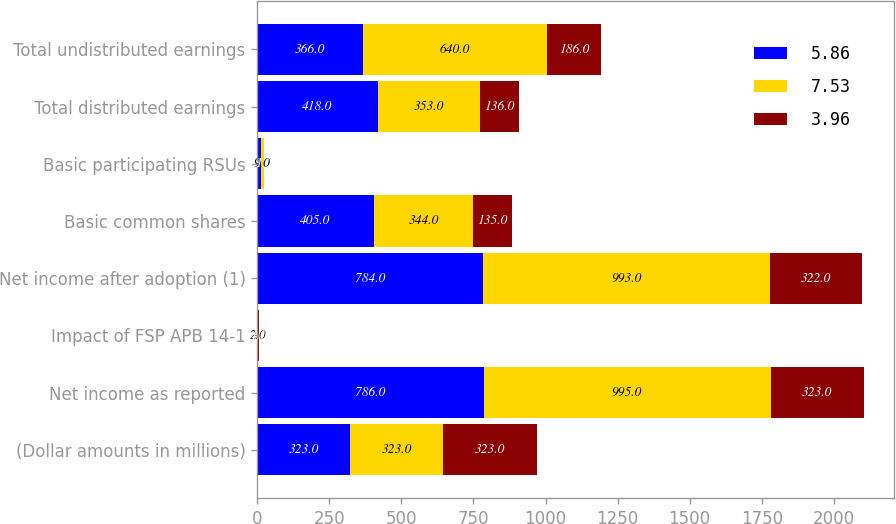Convert chart. <chart><loc_0><loc_0><loc_500><loc_500><stacked_bar_chart><ecel><fcel>(Dollar amounts in millions)<fcel>Net income as reported<fcel>Impact of FSP APB 14-1<fcel>Net income after adoption (1)<fcel>Basic common shares<fcel>Basic participating RSUs<fcel>Total distributed earnings<fcel>Total undistributed earnings<nl><fcel>5.86<fcel>323<fcel>786<fcel>2<fcel>784<fcel>405<fcel>13<fcel>418<fcel>366<nl><fcel>7.53<fcel>323<fcel>995<fcel>2<fcel>993<fcel>344<fcel>9<fcel>353<fcel>640<nl><fcel>3.96<fcel>323<fcel>323<fcel>1<fcel>322<fcel>135<fcel>1<fcel>136<fcel>186<nl></chart> 